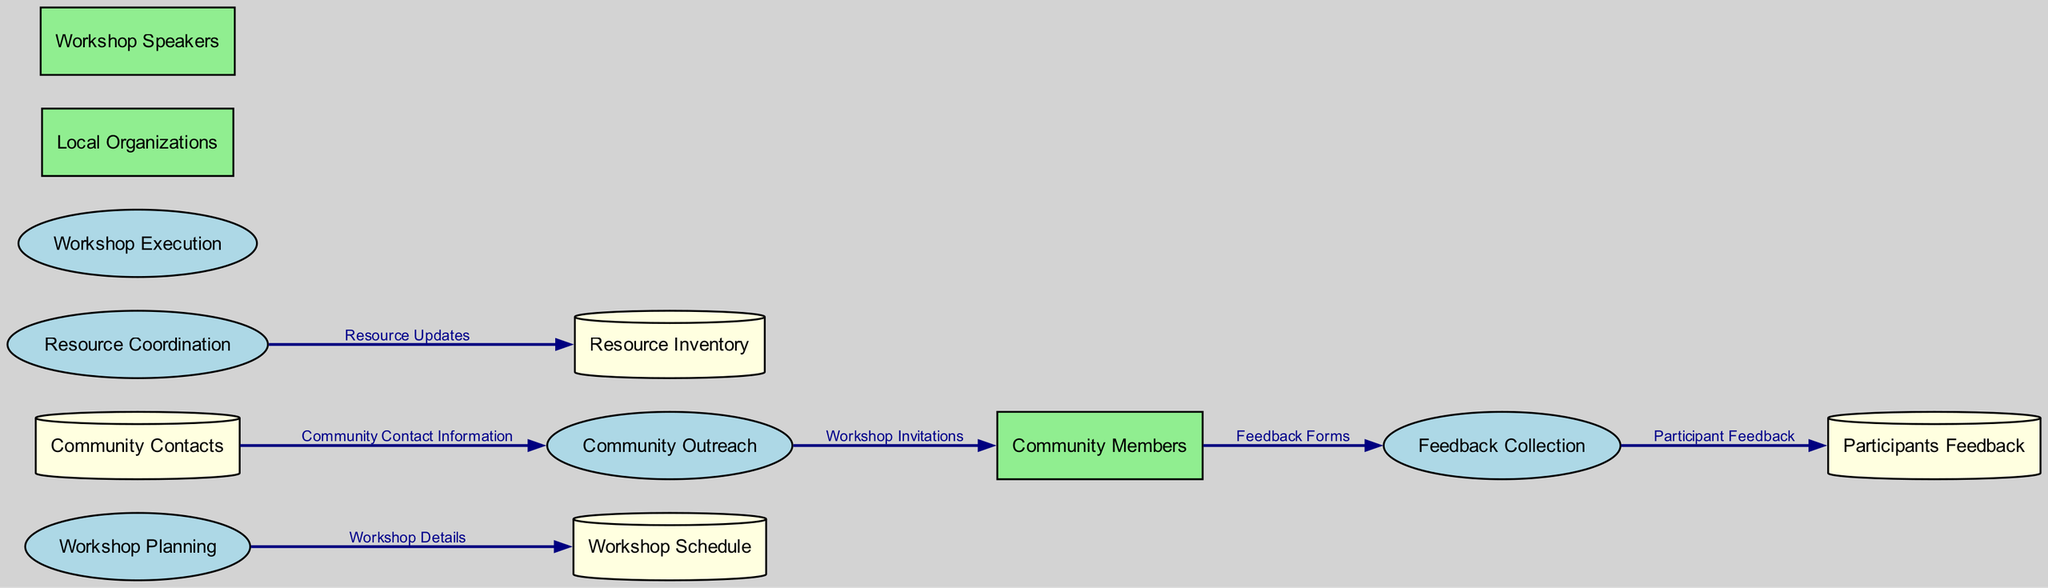What are the names of the processes in the diagram? The processes in the diagram are indicated in the Processes section. There are five processes: Workshop Planning, Community Outreach, Resource Coordination, Workshop Execution, and Feedback Collection.
Answer: Workshop Planning, Community Outreach, Resource Coordination, Workshop Execution, Feedback Collection What data is flowing from Workshop Planning to Workshop Schedule? The data flowing from the Workshop Planning process to the Workshop Schedule data store is labeled as "Workshop Details." This indicates the specific type of information being passed.
Answer: Workshop Details How many external entities are present in the diagram? The number of external entities is counted directly from the External Entities section. There are three external entities listed: Community Members, Local Organizations, and Workshop Speakers.
Answer: 3 What is the purpose of the Community Outreach process? The Community Outreach process is described in the diagram's Processes section and its purpose is to engage with community members to promote the workshop and ensure participation.
Answer: Engage with community members Which process receives feedback forms from Community Members? The feedback forms are collected from Community Members and are directed to the Feedback Collection process, as indicated by the data flow labeled "Feedback Forms."
Answer: Feedback Collection What type of information is stored in the Participants Feedback data store? The Participants Feedback data store is utilized for storing feedback collected from workshop participants, which is specified in the Data Stores section of the diagram.
Answer: Participant Feedback Which data store is updated with resource information? Resource updates are sent from the Resource Coordination process to the Resource Inventory data store, as indicated by the data flow labeled "Resource Updates."
Answer: Resource Inventory Which process conducts the workshop? The process responsible for conducting the workshop is called Workshop Execution, which is detailed in the Processes section of the diagram.
Answer: Workshop Execution What is the data flowing from Community Contacts to Community Outreach? The data flowing from the Community Contacts data store to the Community Outreach process is labeled as "Community Contact Information," which indicates the type of data being provided.
Answer: Community Contact Information 